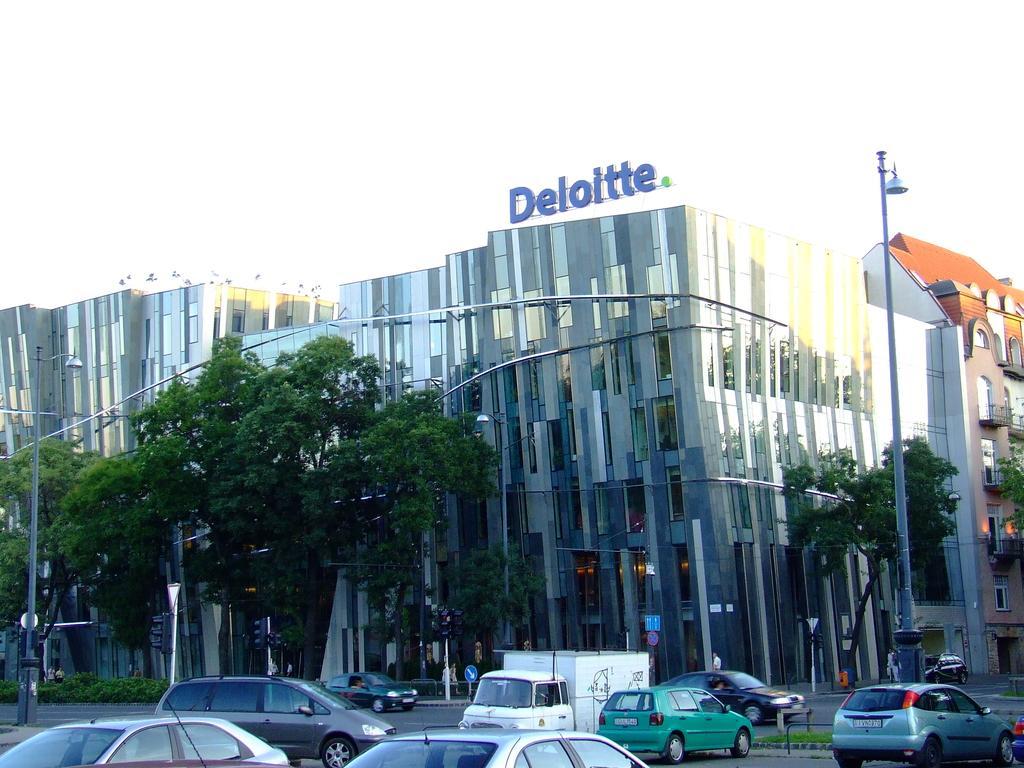Please provide a concise description of this image. There are vehicles on the road. In the background, there are lights attached to the poles, there are trees, buildings, which are having glass windows and there is a sky. 